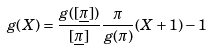<formula> <loc_0><loc_0><loc_500><loc_500>g ( X ) = \frac { g ( [ \underline { \pi } ] ) } { [ \underline { \pi } ] } \frac { \pi } { g ( \pi ) } ( X + 1 ) - 1</formula> 